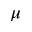<formula> <loc_0><loc_0><loc_500><loc_500>\mu</formula> 